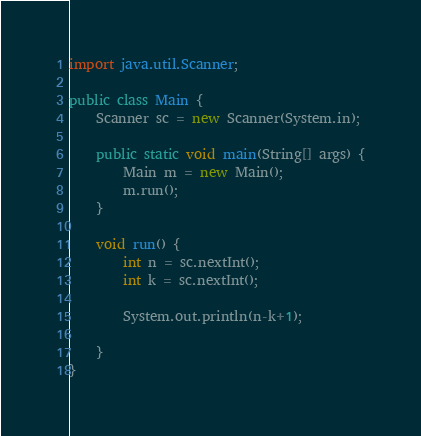Convert code to text. <code><loc_0><loc_0><loc_500><loc_500><_Java_>import java.util.Scanner;

public class Main {
	Scanner sc = new Scanner(System.in);
	
	public static void main(String[] args) {
		Main m = new Main();
		m.run();
	}
	
	void run() {
		int n = sc.nextInt();
		int k = sc.nextInt();
		
		System.out.println(n-k+1);
		
	}
}
</code> 